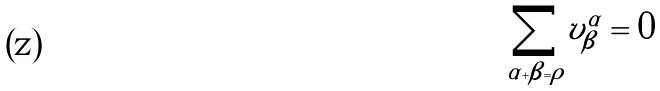<formula> <loc_0><loc_0><loc_500><loc_500>\underset { \alpha + \beta = \rho } { \sum } v _ { \beta } ^ { \alpha } = 0</formula> 